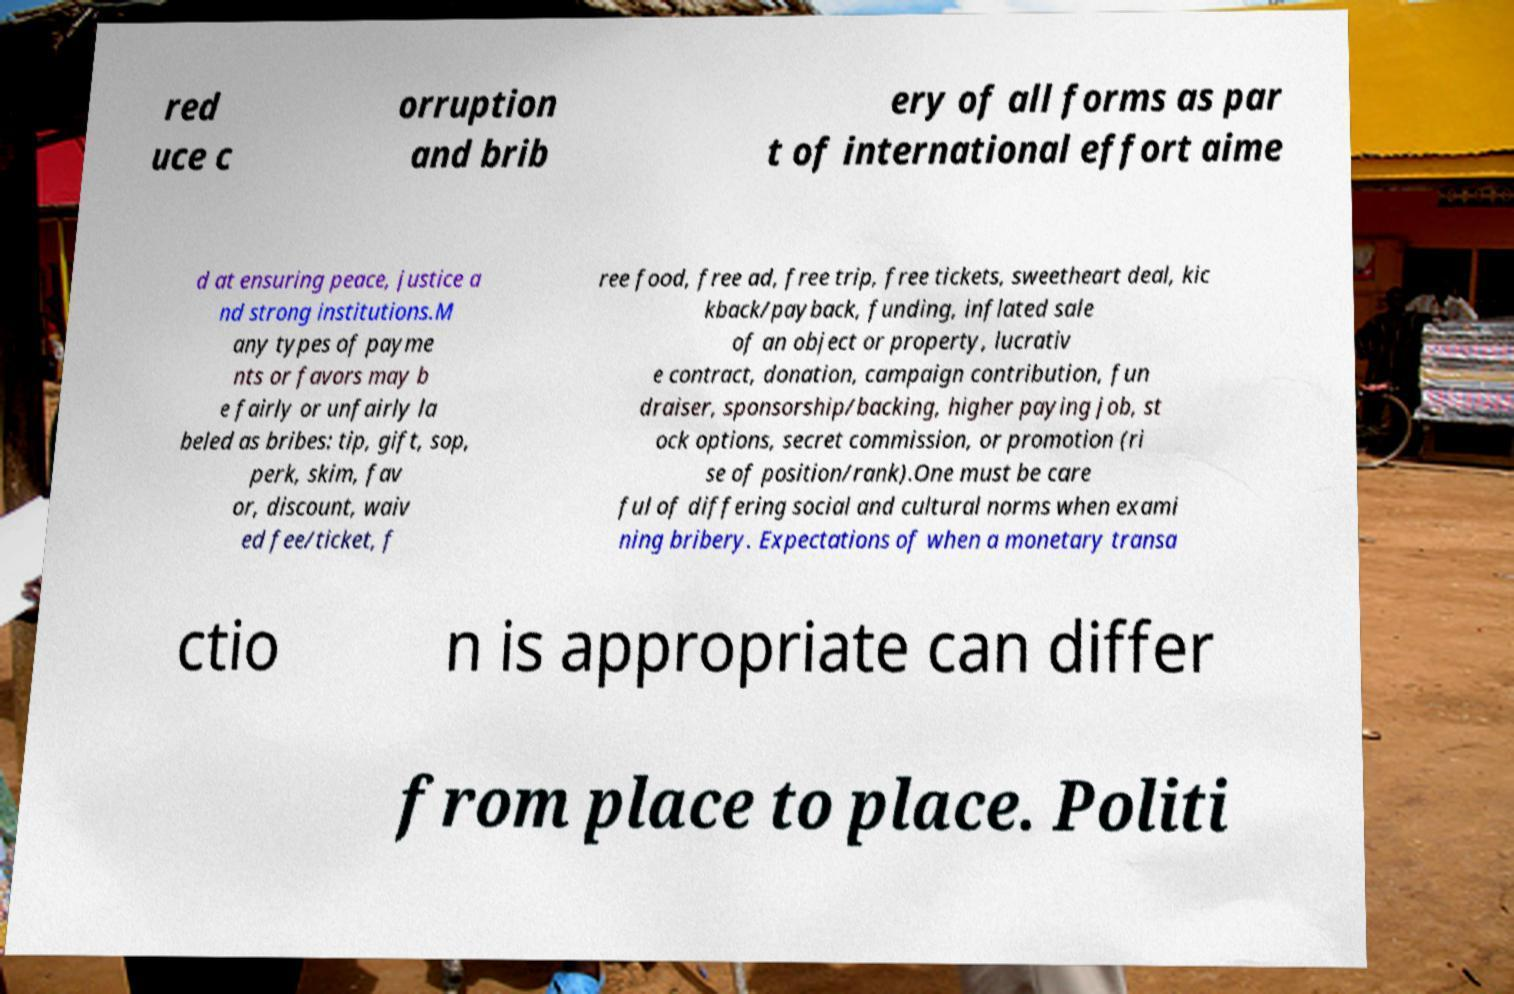For documentation purposes, I need the text within this image transcribed. Could you provide that? red uce c orruption and brib ery of all forms as par t of international effort aime d at ensuring peace, justice a nd strong institutions.M any types of payme nts or favors may b e fairly or unfairly la beled as bribes: tip, gift, sop, perk, skim, fav or, discount, waiv ed fee/ticket, f ree food, free ad, free trip, free tickets, sweetheart deal, kic kback/payback, funding, inflated sale of an object or property, lucrativ e contract, donation, campaign contribution, fun draiser, sponsorship/backing, higher paying job, st ock options, secret commission, or promotion (ri se of position/rank).One must be care ful of differing social and cultural norms when exami ning bribery. Expectations of when a monetary transa ctio n is appropriate can differ from place to place. Politi 